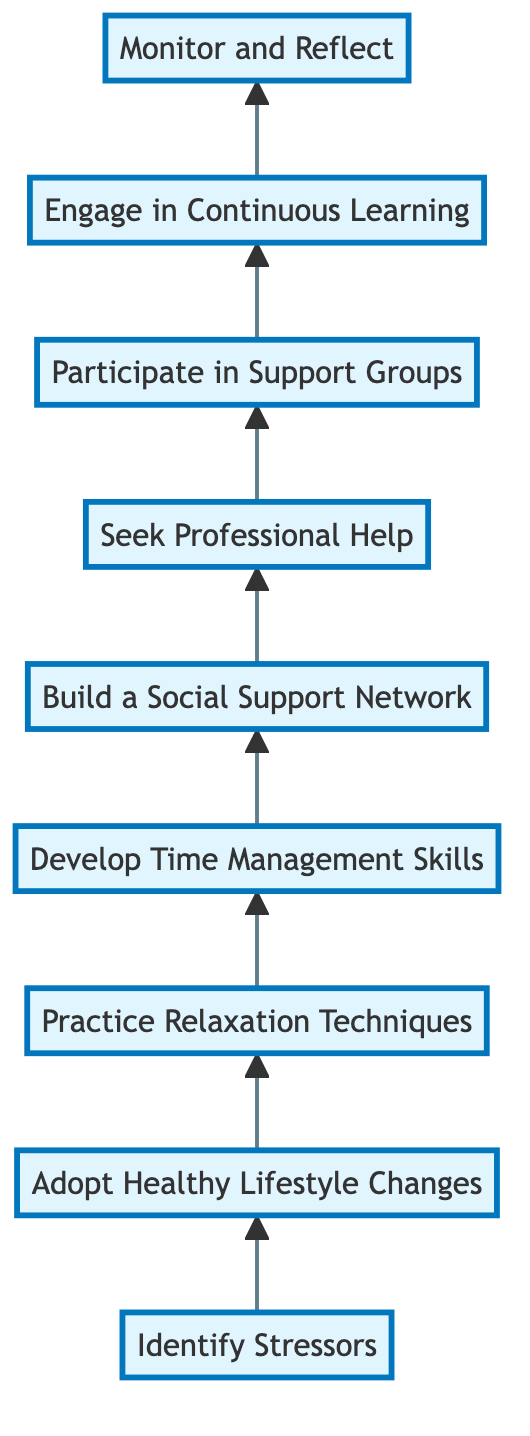What is the first step in achieving optimal mental health? The diagram indicates that the first step is "Identify Stressors." This is the starting point of the flowchart, representing the initial action one should take.
Answer: Identify Stressors How many steps are there in total to achieve optimal mental health according to the diagram? By counting the nodes in the flowchart, there are a total of nine steps outlined from "Identify Stressors" to "Monitor and Reflect."
Answer: 9 What follows after "Build a Social Support Network" in the flow chart? The flowchart shows that "Seek Professional Help" is the next step that follows "Build a Social Support Network." This indicates the progression in seeking further assistance.
Answer: Seek Professional Help Which two steps are directly connected before "Engage in Continuous Learning"? "Participate in Support Groups" and "Seek Professional Help" are the two steps that connect directly before "Engage in Continuous Learning," as shown in the flowchart.
Answer: Participate in Support Groups, Seek Professional Help If a person is practicing relaxation techniques, what step comes next? According to the flowchart, after practicing relaxation techniques, the next step is "Develop Time Management Skills," indicating a sequential approach to improving mental health.
Answer: Develop Time Management Skills What is the last step in the flow chart? The final step in the flowchart is "Monitor and Reflect," which serves as a concluding measure for assessing the progress of one’s mental health journey.
Answer: Monitor and Reflect How does "Adopt Healthy Lifestyle Changes" relate to "Practice Relaxation Techniques"? "Adopt Healthy Lifestyle Changes" leads to "Practice Relaxation Techniques" as depicted by the arrow in the flowchart. This shows that adopting healthy habits is a precursor to practicing relaxation methods.
Answer: Leads to What is the main purpose of "Engage in Continuous Learning"? The purpose of "Engage in Continuous Learning" is to keep informed about mental health, which promotes ongoing awareness and understanding of mental wellness strategies.
Answer: Keep informed about mental health What type of support does "Participate in Support Groups" provide? "Participate in Support Groups" provides community support, reflecting a shared experience and encouragement among individuals dealing with mental health issues.
Answer: Community support 